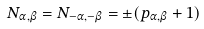<formula> <loc_0><loc_0><loc_500><loc_500>N _ { \alpha , \beta } = N _ { - \alpha , - \beta } = \pm ( p _ { \alpha , \beta } + 1 )</formula> 